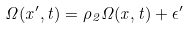Convert formula to latex. <formula><loc_0><loc_0><loc_500><loc_500>\Omega ( x ^ { \prime } , t ) = \rho _ { 2 } \Omega ( x , t ) + \epsilon ^ { \prime }</formula> 